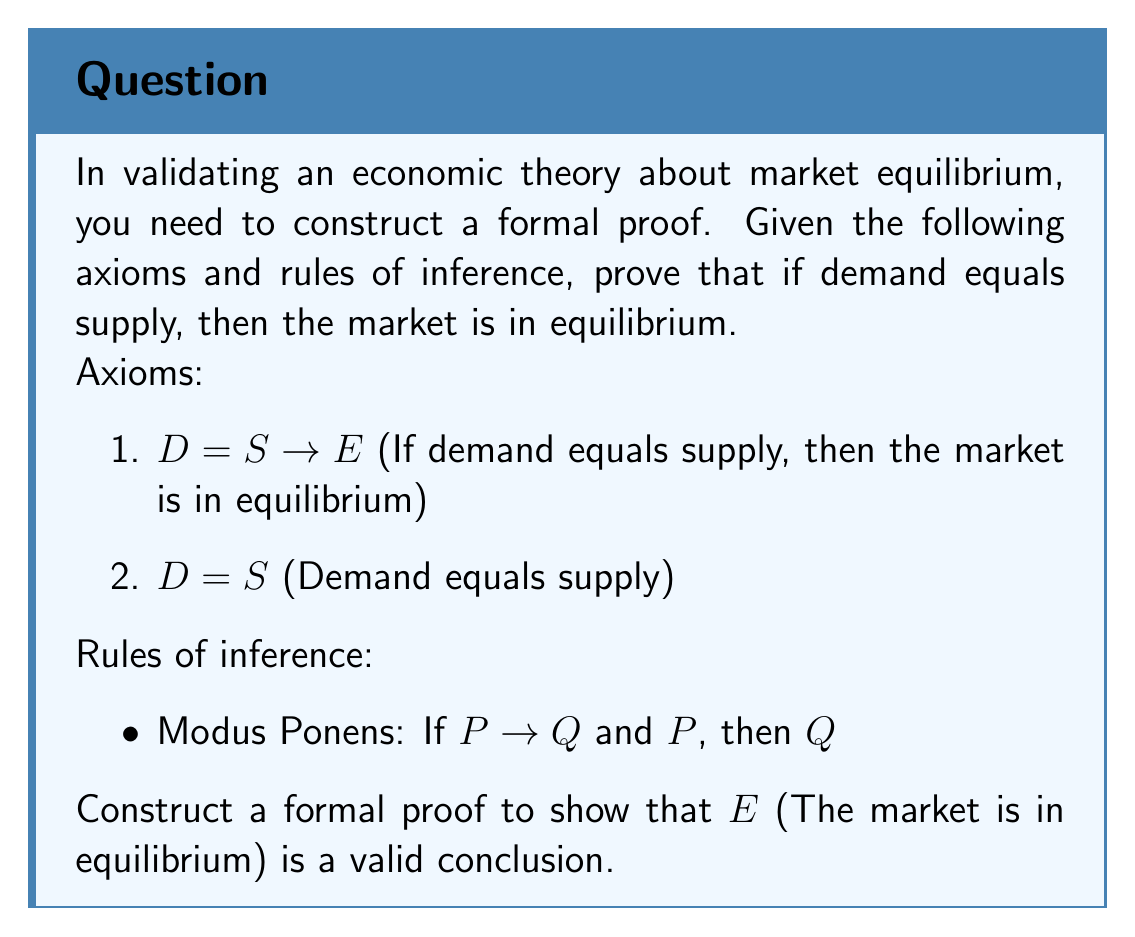Help me with this question. To construct a formal proof for this economic theory, we will use the given axioms and the rule of inference (Modus Ponens) to derive the conclusion. Here's a step-by-step explanation of the proof:

1. Start with the given axioms:
   Axiom 1: $D = S \rightarrow E$
   Axiom 2: $D = S$

2. Apply Modus Ponens:
   - We have $P \rightarrow Q$, where $P$ is $(D = S)$ and $Q$ is $E$
   - We also have $P$, which is $(D = S)$
   - Therefore, we can conclude $Q$, which is $E$

3. Formal proof structure:
   1. $D = S \rightarrow E$ (Axiom 1)
   2. $D = S$ (Axiom 2)
   3. $E$ (Modus Ponens, steps 1 and 2)

This proof demonstrates that given the axioms and using the rule of Modus Ponens, we can validly conclude that the market is in equilibrium $(E)$ when demand equals supply $(D = S)$.
Answer: $E$ (The market is in equilibrium) 